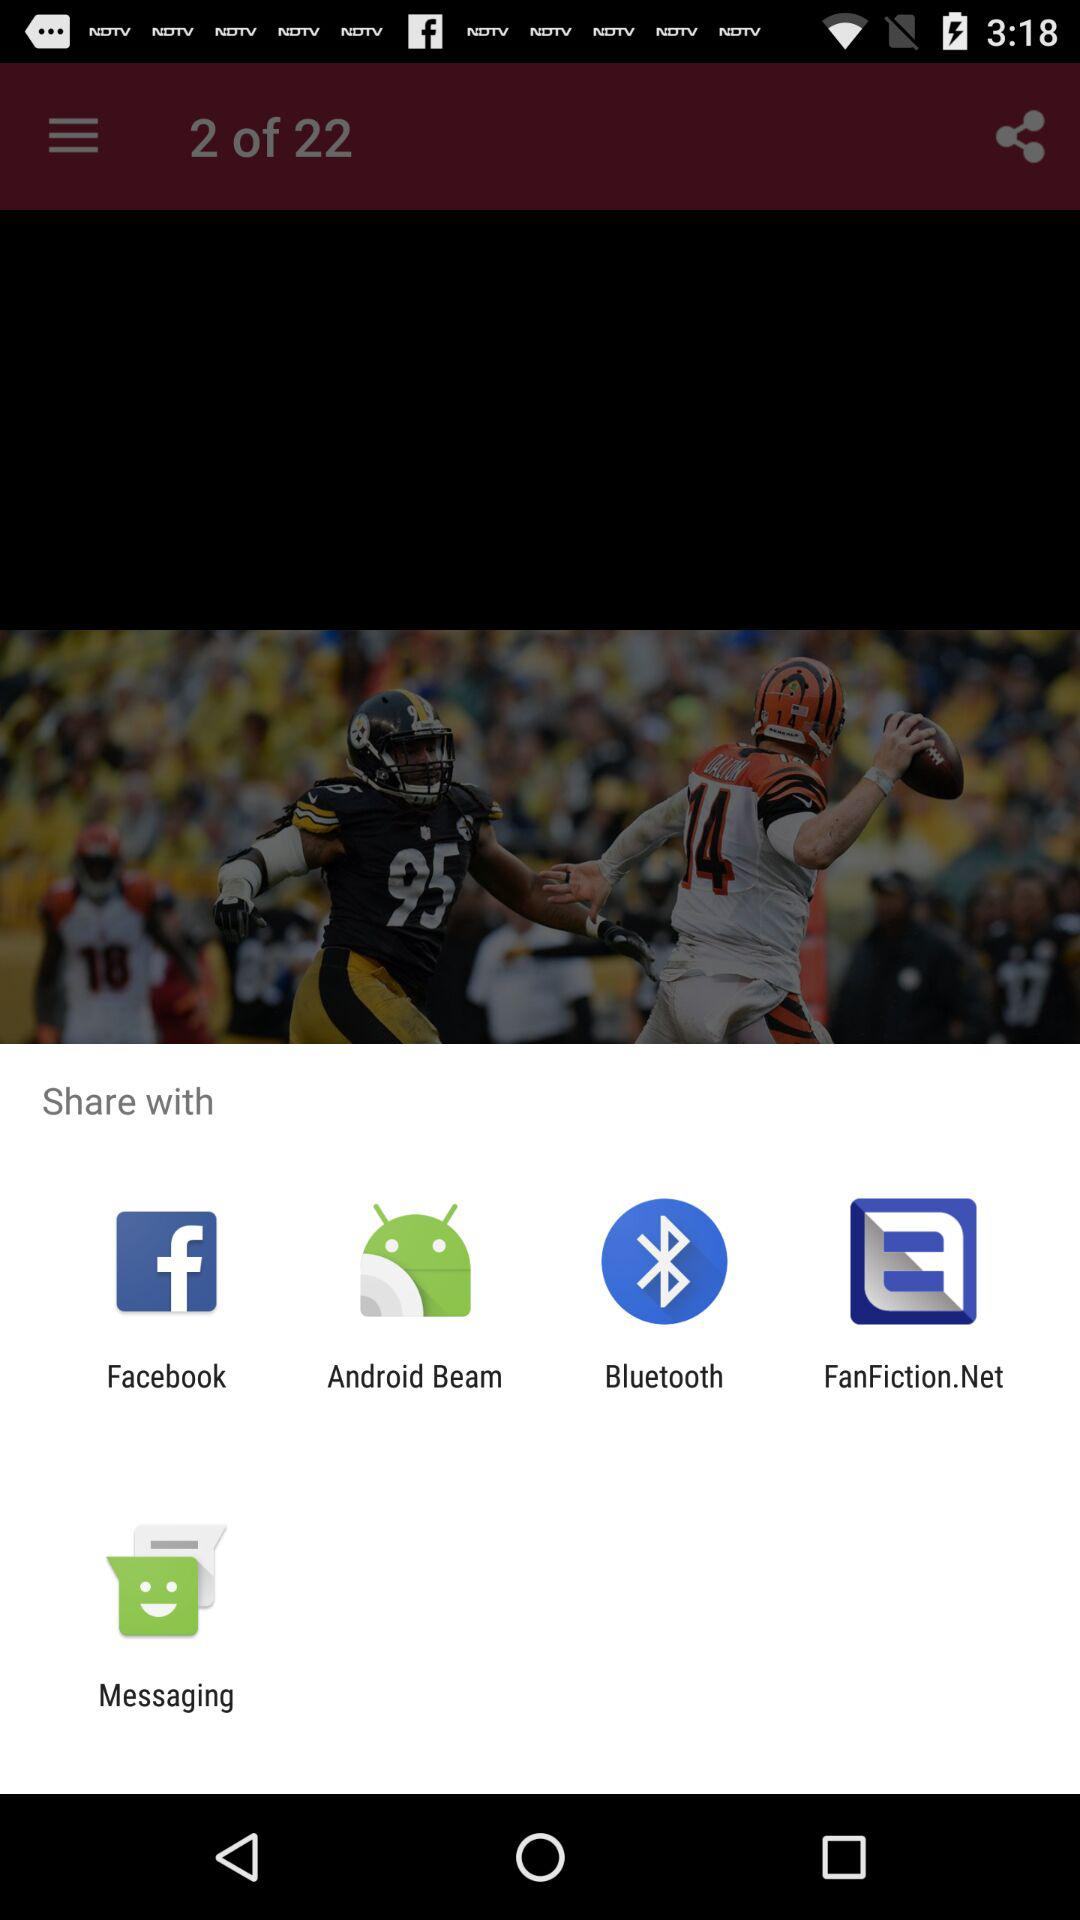Which options are given to share it? The options are "Facebook", "Android Beam", "Bluetooth", "FanFiction.Net" and "Messaging". 